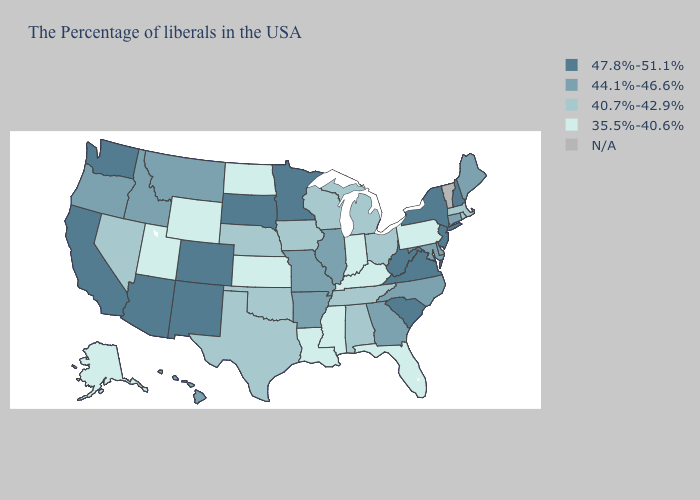Name the states that have a value in the range 47.8%-51.1%?
Give a very brief answer. New Hampshire, New York, New Jersey, Virginia, South Carolina, West Virginia, Minnesota, South Dakota, Colorado, New Mexico, Arizona, California, Washington. What is the value of New York?
Write a very short answer. 47.8%-51.1%. Name the states that have a value in the range 40.7%-42.9%?
Short answer required. Massachusetts, Rhode Island, Ohio, Michigan, Alabama, Tennessee, Wisconsin, Iowa, Nebraska, Oklahoma, Texas, Nevada. Among the states that border New Jersey , which have the lowest value?
Quick response, please. Pennsylvania. What is the value of Virginia?
Quick response, please. 47.8%-51.1%. What is the lowest value in states that border Missouri?
Answer briefly. 35.5%-40.6%. Which states have the highest value in the USA?
Quick response, please. New Hampshire, New York, New Jersey, Virginia, South Carolina, West Virginia, Minnesota, South Dakota, Colorado, New Mexico, Arizona, California, Washington. Name the states that have a value in the range 47.8%-51.1%?
Be succinct. New Hampshire, New York, New Jersey, Virginia, South Carolina, West Virginia, Minnesota, South Dakota, Colorado, New Mexico, Arizona, California, Washington. What is the value of New Jersey?
Write a very short answer. 47.8%-51.1%. What is the value of Pennsylvania?
Be succinct. 35.5%-40.6%. Among the states that border Washington , which have the lowest value?
Write a very short answer. Idaho, Oregon. Name the states that have a value in the range 35.5%-40.6%?
Concise answer only. Pennsylvania, Florida, Kentucky, Indiana, Mississippi, Louisiana, Kansas, North Dakota, Wyoming, Utah, Alaska. 